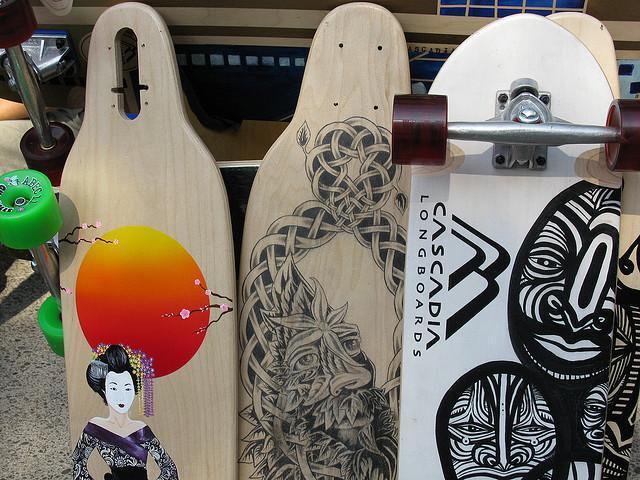How many skateboards are there?
Give a very brief answer. 4. 